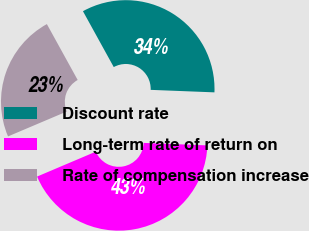Convert chart to OTSL. <chart><loc_0><loc_0><loc_500><loc_500><pie_chart><fcel>Discount rate<fcel>Long-term rate of return on<fcel>Rate of compensation increase<nl><fcel>33.64%<fcel>42.99%<fcel>23.36%<nl></chart> 